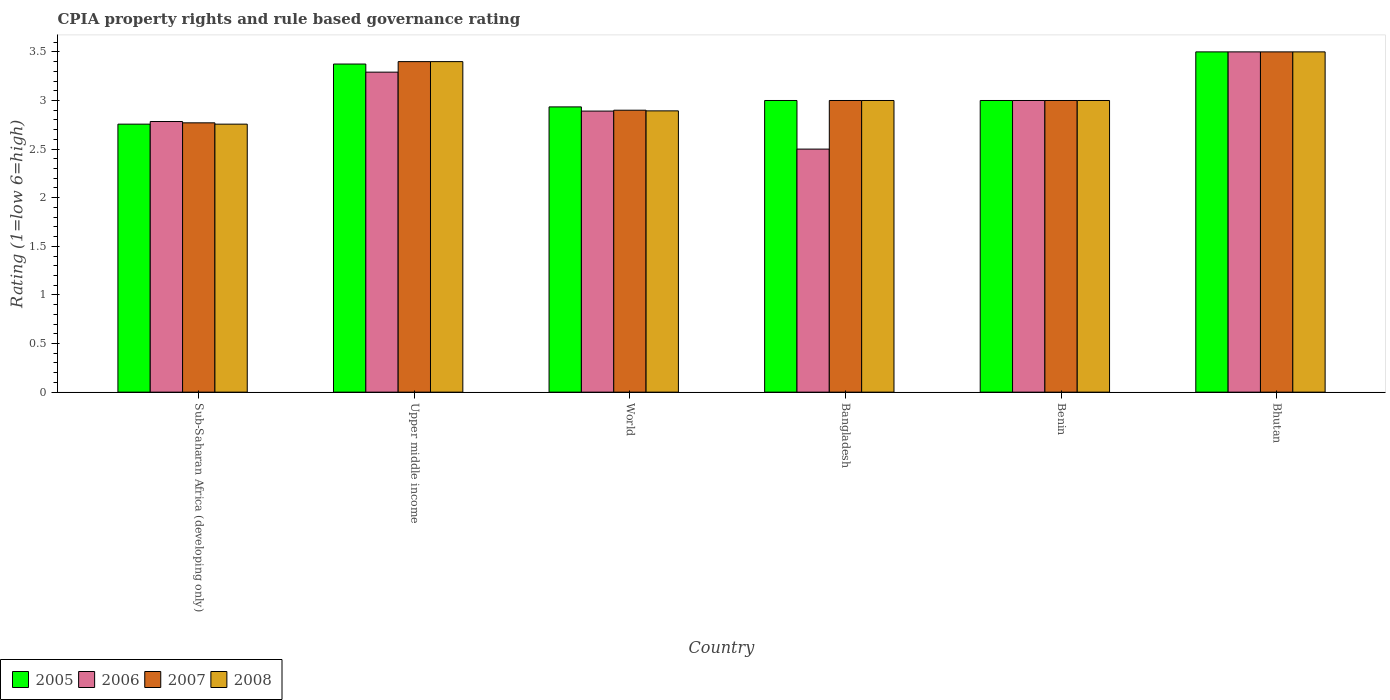How many different coloured bars are there?
Give a very brief answer. 4. How many groups of bars are there?
Ensure brevity in your answer.  6. Are the number of bars on each tick of the X-axis equal?
Your response must be concise. Yes. How many bars are there on the 5th tick from the left?
Give a very brief answer. 4. How many bars are there on the 6th tick from the right?
Ensure brevity in your answer.  4. What is the label of the 2nd group of bars from the left?
Your answer should be compact. Upper middle income. In how many cases, is the number of bars for a given country not equal to the number of legend labels?
Give a very brief answer. 0. What is the CPIA rating in 2008 in Sub-Saharan Africa (developing only)?
Keep it short and to the point. 2.76. Across all countries, what is the maximum CPIA rating in 2007?
Your answer should be compact. 3.5. Across all countries, what is the minimum CPIA rating in 2007?
Keep it short and to the point. 2.77. In which country was the CPIA rating in 2006 maximum?
Your answer should be very brief. Bhutan. In which country was the CPIA rating in 2007 minimum?
Your response must be concise. Sub-Saharan Africa (developing only). What is the total CPIA rating in 2008 in the graph?
Provide a succinct answer. 18.55. What is the difference between the CPIA rating in 2008 in Bangladesh and that in Sub-Saharan Africa (developing only)?
Offer a very short reply. 0.24. What is the difference between the CPIA rating in 2006 in Benin and the CPIA rating in 2007 in Sub-Saharan Africa (developing only)?
Your answer should be very brief. 0.23. What is the average CPIA rating in 2006 per country?
Offer a very short reply. 2.99. What is the difference between the CPIA rating of/in 2007 and CPIA rating of/in 2006 in Benin?
Ensure brevity in your answer.  0. In how many countries, is the CPIA rating in 2006 greater than 0.9?
Keep it short and to the point. 6. What is the ratio of the CPIA rating in 2006 in Upper middle income to that in World?
Offer a terse response. 1.14. Is the CPIA rating in 2007 in Bhutan less than that in Upper middle income?
Your response must be concise. No. Is the difference between the CPIA rating in 2007 in Bangladesh and World greater than the difference between the CPIA rating in 2006 in Bangladesh and World?
Your answer should be very brief. Yes. What is the difference between the highest and the second highest CPIA rating in 2008?
Keep it short and to the point. 0.4. What is the difference between the highest and the lowest CPIA rating in 2007?
Keep it short and to the point. 0.73. In how many countries, is the CPIA rating in 2008 greater than the average CPIA rating in 2008 taken over all countries?
Provide a short and direct response. 2. Is the sum of the CPIA rating in 2006 in Benin and World greater than the maximum CPIA rating in 2005 across all countries?
Your answer should be very brief. Yes. Is it the case that in every country, the sum of the CPIA rating in 2007 and CPIA rating in 2005 is greater than the sum of CPIA rating in 2008 and CPIA rating in 2006?
Provide a succinct answer. Yes. What does the 4th bar from the left in Benin represents?
Your response must be concise. 2008. What does the 4th bar from the right in Benin represents?
Provide a succinct answer. 2005. Are all the bars in the graph horizontal?
Keep it short and to the point. No. How many countries are there in the graph?
Make the answer very short. 6. What is the difference between two consecutive major ticks on the Y-axis?
Your answer should be very brief. 0.5. Does the graph contain any zero values?
Your answer should be very brief. No. How many legend labels are there?
Give a very brief answer. 4. What is the title of the graph?
Offer a very short reply. CPIA property rights and rule based governance rating. Does "1999" appear as one of the legend labels in the graph?
Your answer should be very brief. No. What is the label or title of the X-axis?
Keep it short and to the point. Country. What is the Rating (1=low 6=high) in 2005 in Sub-Saharan Africa (developing only)?
Offer a very short reply. 2.76. What is the Rating (1=low 6=high) of 2006 in Sub-Saharan Africa (developing only)?
Provide a succinct answer. 2.78. What is the Rating (1=low 6=high) in 2007 in Sub-Saharan Africa (developing only)?
Your answer should be very brief. 2.77. What is the Rating (1=low 6=high) of 2008 in Sub-Saharan Africa (developing only)?
Offer a very short reply. 2.76. What is the Rating (1=low 6=high) of 2005 in Upper middle income?
Your answer should be very brief. 3.38. What is the Rating (1=low 6=high) in 2006 in Upper middle income?
Give a very brief answer. 3.29. What is the Rating (1=low 6=high) in 2005 in World?
Provide a short and direct response. 2.93. What is the Rating (1=low 6=high) in 2006 in World?
Keep it short and to the point. 2.89. What is the Rating (1=low 6=high) in 2007 in World?
Offer a very short reply. 2.9. What is the Rating (1=low 6=high) of 2008 in World?
Provide a short and direct response. 2.89. What is the Rating (1=low 6=high) of 2006 in Bangladesh?
Provide a short and direct response. 2.5. What is the Rating (1=low 6=high) of 2008 in Bangladesh?
Give a very brief answer. 3. What is the Rating (1=low 6=high) of 2005 in Benin?
Ensure brevity in your answer.  3. What is the Rating (1=low 6=high) of 2008 in Benin?
Give a very brief answer. 3. What is the Rating (1=low 6=high) of 2007 in Bhutan?
Your answer should be very brief. 3.5. What is the Rating (1=low 6=high) in 2008 in Bhutan?
Ensure brevity in your answer.  3.5. Across all countries, what is the maximum Rating (1=low 6=high) in 2005?
Your answer should be compact. 3.5. Across all countries, what is the maximum Rating (1=low 6=high) of 2007?
Your response must be concise. 3.5. Across all countries, what is the maximum Rating (1=low 6=high) of 2008?
Make the answer very short. 3.5. Across all countries, what is the minimum Rating (1=low 6=high) of 2005?
Your answer should be compact. 2.76. Across all countries, what is the minimum Rating (1=low 6=high) of 2007?
Your response must be concise. 2.77. Across all countries, what is the minimum Rating (1=low 6=high) in 2008?
Provide a short and direct response. 2.76. What is the total Rating (1=low 6=high) of 2005 in the graph?
Offer a terse response. 18.57. What is the total Rating (1=low 6=high) in 2006 in the graph?
Your answer should be compact. 17.97. What is the total Rating (1=low 6=high) of 2007 in the graph?
Your answer should be compact. 18.57. What is the total Rating (1=low 6=high) in 2008 in the graph?
Provide a short and direct response. 18.55. What is the difference between the Rating (1=low 6=high) of 2005 in Sub-Saharan Africa (developing only) and that in Upper middle income?
Ensure brevity in your answer.  -0.62. What is the difference between the Rating (1=low 6=high) in 2006 in Sub-Saharan Africa (developing only) and that in Upper middle income?
Keep it short and to the point. -0.51. What is the difference between the Rating (1=low 6=high) of 2007 in Sub-Saharan Africa (developing only) and that in Upper middle income?
Your response must be concise. -0.63. What is the difference between the Rating (1=low 6=high) in 2008 in Sub-Saharan Africa (developing only) and that in Upper middle income?
Offer a very short reply. -0.64. What is the difference between the Rating (1=low 6=high) in 2005 in Sub-Saharan Africa (developing only) and that in World?
Give a very brief answer. -0.18. What is the difference between the Rating (1=low 6=high) in 2006 in Sub-Saharan Africa (developing only) and that in World?
Your answer should be compact. -0.11. What is the difference between the Rating (1=low 6=high) of 2007 in Sub-Saharan Africa (developing only) and that in World?
Keep it short and to the point. -0.13. What is the difference between the Rating (1=low 6=high) of 2008 in Sub-Saharan Africa (developing only) and that in World?
Your response must be concise. -0.14. What is the difference between the Rating (1=low 6=high) of 2005 in Sub-Saharan Africa (developing only) and that in Bangladesh?
Keep it short and to the point. -0.24. What is the difference between the Rating (1=low 6=high) in 2006 in Sub-Saharan Africa (developing only) and that in Bangladesh?
Offer a very short reply. 0.28. What is the difference between the Rating (1=low 6=high) of 2007 in Sub-Saharan Africa (developing only) and that in Bangladesh?
Keep it short and to the point. -0.23. What is the difference between the Rating (1=low 6=high) in 2008 in Sub-Saharan Africa (developing only) and that in Bangladesh?
Ensure brevity in your answer.  -0.24. What is the difference between the Rating (1=low 6=high) in 2005 in Sub-Saharan Africa (developing only) and that in Benin?
Your answer should be compact. -0.24. What is the difference between the Rating (1=low 6=high) in 2006 in Sub-Saharan Africa (developing only) and that in Benin?
Make the answer very short. -0.22. What is the difference between the Rating (1=low 6=high) of 2007 in Sub-Saharan Africa (developing only) and that in Benin?
Your answer should be compact. -0.23. What is the difference between the Rating (1=low 6=high) of 2008 in Sub-Saharan Africa (developing only) and that in Benin?
Your response must be concise. -0.24. What is the difference between the Rating (1=low 6=high) in 2005 in Sub-Saharan Africa (developing only) and that in Bhutan?
Your answer should be very brief. -0.74. What is the difference between the Rating (1=low 6=high) of 2006 in Sub-Saharan Africa (developing only) and that in Bhutan?
Make the answer very short. -0.72. What is the difference between the Rating (1=low 6=high) of 2007 in Sub-Saharan Africa (developing only) and that in Bhutan?
Provide a succinct answer. -0.73. What is the difference between the Rating (1=low 6=high) in 2008 in Sub-Saharan Africa (developing only) and that in Bhutan?
Offer a very short reply. -0.74. What is the difference between the Rating (1=low 6=high) of 2005 in Upper middle income and that in World?
Offer a terse response. 0.44. What is the difference between the Rating (1=low 6=high) of 2006 in Upper middle income and that in World?
Your answer should be very brief. 0.4. What is the difference between the Rating (1=low 6=high) in 2007 in Upper middle income and that in World?
Ensure brevity in your answer.  0.5. What is the difference between the Rating (1=low 6=high) in 2008 in Upper middle income and that in World?
Your answer should be compact. 0.51. What is the difference between the Rating (1=low 6=high) in 2006 in Upper middle income and that in Bangladesh?
Your answer should be compact. 0.79. What is the difference between the Rating (1=low 6=high) in 2007 in Upper middle income and that in Bangladesh?
Your answer should be very brief. 0.4. What is the difference between the Rating (1=low 6=high) in 2005 in Upper middle income and that in Benin?
Offer a very short reply. 0.38. What is the difference between the Rating (1=low 6=high) in 2006 in Upper middle income and that in Benin?
Your answer should be very brief. 0.29. What is the difference between the Rating (1=low 6=high) of 2008 in Upper middle income and that in Benin?
Ensure brevity in your answer.  0.4. What is the difference between the Rating (1=low 6=high) of 2005 in Upper middle income and that in Bhutan?
Offer a terse response. -0.12. What is the difference between the Rating (1=low 6=high) in 2006 in Upper middle income and that in Bhutan?
Offer a very short reply. -0.21. What is the difference between the Rating (1=low 6=high) in 2007 in Upper middle income and that in Bhutan?
Make the answer very short. -0.1. What is the difference between the Rating (1=low 6=high) in 2008 in Upper middle income and that in Bhutan?
Offer a terse response. -0.1. What is the difference between the Rating (1=low 6=high) in 2005 in World and that in Bangladesh?
Ensure brevity in your answer.  -0.07. What is the difference between the Rating (1=low 6=high) in 2006 in World and that in Bangladesh?
Give a very brief answer. 0.39. What is the difference between the Rating (1=low 6=high) of 2008 in World and that in Bangladesh?
Give a very brief answer. -0.11. What is the difference between the Rating (1=low 6=high) in 2005 in World and that in Benin?
Your answer should be compact. -0.07. What is the difference between the Rating (1=low 6=high) in 2006 in World and that in Benin?
Provide a succinct answer. -0.11. What is the difference between the Rating (1=low 6=high) in 2008 in World and that in Benin?
Your response must be concise. -0.11. What is the difference between the Rating (1=low 6=high) in 2005 in World and that in Bhutan?
Your answer should be very brief. -0.57. What is the difference between the Rating (1=low 6=high) in 2006 in World and that in Bhutan?
Ensure brevity in your answer.  -0.61. What is the difference between the Rating (1=low 6=high) in 2008 in World and that in Bhutan?
Make the answer very short. -0.61. What is the difference between the Rating (1=low 6=high) of 2005 in Bangladesh and that in Benin?
Offer a very short reply. 0. What is the difference between the Rating (1=low 6=high) in 2006 in Bangladesh and that in Benin?
Offer a terse response. -0.5. What is the difference between the Rating (1=low 6=high) of 2008 in Bangladesh and that in Benin?
Make the answer very short. 0. What is the difference between the Rating (1=low 6=high) in 2005 in Bangladesh and that in Bhutan?
Offer a terse response. -0.5. What is the difference between the Rating (1=low 6=high) in 2006 in Bangladesh and that in Bhutan?
Your response must be concise. -1. What is the difference between the Rating (1=low 6=high) of 2007 in Bangladesh and that in Bhutan?
Ensure brevity in your answer.  -0.5. What is the difference between the Rating (1=low 6=high) in 2008 in Bangladesh and that in Bhutan?
Keep it short and to the point. -0.5. What is the difference between the Rating (1=low 6=high) of 2005 in Benin and that in Bhutan?
Make the answer very short. -0.5. What is the difference between the Rating (1=low 6=high) in 2007 in Benin and that in Bhutan?
Your answer should be compact. -0.5. What is the difference between the Rating (1=low 6=high) of 2005 in Sub-Saharan Africa (developing only) and the Rating (1=low 6=high) of 2006 in Upper middle income?
Offer a very short reply. -0.53. What is the difference between the Rating (1=low 6=high) of 2005 in Sub-Saharan Africa (developing only) and the Rating (1=low 6=high) of 2007 in Upper middle income?
Make the answer very short. -0.64. What is the difference between the Rating (1=low 6=high) in 2005 in Sub-Saharan Africa (developing only) and the Rating (1=low 6=high) in 2008 in Upper middle income?
Your answer should be compact. -0.64. What is the difference between the Rating (1=low 6=high) in 2006 in Sub-Saharan Africa (developing only) and the Rating (1=low 6=high) in 2007 in Upper middle income?
Offer a very short reply. -0.62. What is the difference between the Rating (1=low 6=high) of 2006 in Sub-Saharan Africa (developing only) and the Rating (1=low 6=high) of 2008 in Upper middle income?
Keep it short and to the point. -0.62. What is the difference between the Rating (1=low 6=high) of 2007 in Sub-Saharan Africa (developing only) and the Rating (1=low 6=high) of 2008 in Upper middle income?
Keep it short and to the point. -0.63. What is the difference between the Rating (1=low 6=high) in 2005 in Sub-Saharan Africa (developing only) and the Rating (1=low 6=high) in 2006 in World?
Ensure brevity in your answer.  -0.13. What is the difference between the Rating (1=low 6=high) in 2005 in Sub-Saharan Africa (developing only) and the Rating (1=low 6=high) in 2007 in World?
Offer a very short reply. -0.14. What is the difference between the Rating (1=low 6=high) in 2005 in Sub-Saharan Africa (developing only) and the Rating (1=low 6=high) in 2008 in World?
Your answer should be very brief. -0.14. What is the difference between the Rating (1=low 6=high) of 2006 in Sub-Saharan Africa (developing only) and the Rating (1=low 6=high) of 2007 in World?
Your response must be concise. -0.12. What is the difference between the Rating (1=low 6=high) in 2006 in Sub-Saharan Africa (developing only) and the Rating (1=low 6=high) in 2008 in World?
Your answer should be very brief. -0.11. What is the difference between the Rating (1=low 6=high) of 2007 in Sub-Saharan Africa (developing only) and the Rating (1=low 6=high) of 2008 in World?
Provide a succinct answer. -0.12. What is the difference between the Rating (1=low 6=high) of 2005 in Sub-Saharan Africa (developing only) and the Rating (1=low 6=high) of 2006 in Bangladesh?
Offer a terse response. 0.26. What is the difference between the Rating (1=low 6=high) in 2005 in Sub-Saharan Africa (developing only) and the Rating (1=low 6=high) in 2007 in Bangladesh?
Ensure brevity in your answer.  -0.24. What is the difference between the Rating (1=low 6=high) of 2005 in Sub-Saharan Africa (developing only) and the Rating (1=low 6=high) of 2008 in Bangladesh?
Offer a very short reply. -0.24. What is the difference between the Rating (1=low 6=high) of 2006 in Sub-Saharan Africa (developing only) and the Rating (1=low 6=high) of 2007 in Bangladesh?
Keep it short and to the point. -0.22. What is the difference between the Rating (1=low 6=high) of 2006 in Sub-Saharan Africa (developing only) and the Rating (1=low 6=high) of 2008 in Bangladesh?
Your answer should be compact. -0.22. What is the difference between the Rating (1=low 6=high) of 2007 in Sub-Saharan Africa (developing only) and the Rating (1=low 6=high) of 2008 in Bangladesh?
Provide a succinct answer. -0.23. What is the difference between the Rating (1=low 6=high) of 2005 in Sub-Saharan Africa (developing only) and the Rating (1=low 6=high) of 2006 in Benin?
Give a very brief answer. -0.24. What is the difference between the Rating (1=low 6=high) of 2005 in Sub-Saharan Africa (developing only) and the Rating (1=low 6=high) of 2007 in Benin?
Make the answer very short. -0.24. What is the difference between the Rating (1=low 6=high) in 2005 in Sub-Saharan Africa (developing only) and the Rating (1=low 6=high) in 2008 in Benin?
Provide a succinct answer. -0.24. What is the difference between the Rating (1=low 6=high) of 2006 in Sub-Saharan Africa (developing only) and the Rating (1=low 6=high) of 2007 in Benin?
Provide a short and direct response. -0.22. What is the difference between the Rating (1=low 6=high) of 2006 in Sub-Saharan Africa (developing only) and the Rating (1=low 6=high) of 2008 in Benin?
Your answer should be very brief. -0.22. What is the difference between the Rating (1=low 6=high) in 2007 in Sub-Saharan Africa (developing only) and the Rating (1=low 6=high) in 2008 in Benin?
Offer a very short reply. -0.23. What is the difference between the Rating (1=low 6=high) in 2005 in Sub-Saharan Africa (developing only) and the Rating (1=low 6=high) in 2006 in Bhutan?
Provide a succinct answer. -0.74. What is the difference between the Rating (1=low 6=high) of 2005 in Sub-Saharan Africa (developing only) and the Rating (1=low 6=high) of 2007 in Bhutan?
Your answer should be very brief. -0.74. What is the difference between the Rating (1=low 6=high) of 2005 in Sub-Saharan Africa (developing only) and the Rating (1=low 6=high) of 2008 in Bhutan?
Your answer should be very brief. -0.74. What is the difference between the Rating (1=low 6=high) of 2006 in Sub-Saharan Africa (developing only) and the Rating (1=low 6=high) of 2007 in Bhutan?
Offer a very short reply. -0.72. What is the difference between the Rating (1=low 6=high) in 2006 in Sub-Saharan Africa (developing only) and the Rating (1=low 6=high) in 2008 in Bhutan?
Offer a terse response. -0.72. What is the difference between the Rating (1=low 6=high) of 2007 in Sub-Saharan Africa (developing only) and the Rating (1=low 6=high) of 2008 in Bhutan?
Your response must be concise. -0.73. What is the difference between the Rating (1=low 6=high) of 2005 in Upper middle income and the Rating (1=low 6=high) of 2006 in World?
Your response must be concise. 0.48. What is the difference between the Rating (1=low 6=high) in 2005 in Upper middle income and the Rating (1=low 6=high) in 2007 in World?
Offer a very short reply. 0.47. What is the difference between the Rating (1=low 6=high) in 2005 in Upper middle income and the Rating (1=low 6=high) in 2008 in World?
Provide a short and direct response. 0.48. What is the difference between the Rating (1=low 6=high) in 2006 in Upper middle income and the Rating (1=low 6=high) in 2007 in World?
Your answer should be compact. 0.39. What is the difference between the Rating (1=low 6=high) of 2006 in Upper middle income and the Rating (1=low 6=high) of 2008 in World?
Offer a terse response. 0.4. What is the difference between the Rating (1=low 6=high) in 2007 in Upper middle income and the Rating (1=low 6=high) in 2008 in World?
Give a very brief answer. 0.51. What is the difference between the Rating (1=low 6=high) in 2006 in Upper middle income and the Rating (1=low 6=high) in 2007 in Bangladesh?
Your answer should be very brief. 0.29. What is the difference between the Rating (1=low 6=high) of 2006 in Upper middle income and the Rating (1=low 6=high) of 2008 in Bangladesh?
Ensure brevity in your answer.  0.29. What is the difference between the Rating (1=low 6=high) in 2006 in Upper middle income and the Rating (1=low 6=high) in 2007 in Benin?
Provide a short and direct response. 0.29. What is the difference between the Rating (1=low 6=high) in 2006 in Upper middle income and the Rating (1=low 6=high) in 2008 in Benin?
Provide a succinct answer. 0.29. What is the difference between the Rating (1=low 6=high) in 2005 in Upper middle income and the Rating (1=low 6=high) in 2006 in Bhutan?
Give a very brief answer. -0.12. What is the difference between the Rating (1=low 6=high) of 2005 in Upper middle income and the Rating (1=low 6=high) of 2007 in Bhutan?
Offer a terse response. -0.12. What is the difference between the Rating (1=low 6=high) in 2005 in Upper middle income and the Rating (1=low 6=high) in 2008 in Bhutan?
Offer a very short reply. -0.12. What is the difference between the Rating (1=low 6=high) in 2006 in Upper middle income and the Rating (1=low 6=high) in 2007 in Bhutan?
Keep it short and to the point. -0.21. What is the difference between the Rating (1=low 6=high) of 2006 in Upper middle income and the Rating (1=low 6=high) of 2008 in Bhutan?
Your response must be concise. -0.21. What is the difference between the Rating (1=low 6=high) of 2007 in Upper middle income and the Rating (1=low 6=high) of 2008 in Bhutan?
Your answer should be very brief. -0.1. What is the difference between the Rating (1=low 6=high) in 2005 in World and the Rating (1=low 6=high) in 2006 in Bangladesh?
Give a very brief answer. 0.43. What is the difference between the Rating (1=low 6=high) of 2005 in World and the Rating (1=low 6=high) of 2007 in Bangladesh?
Keep it short and to the point. -0.07. What is the difference between the Rating (1=low 6=high) of 2005 in World and the Rating (1=low 6=high) of 2008 in Bangladesh?
Your answer should be very brief. -0.07. What is the difference between the Rating (1=low 6=high) in 2006 in World and the Rating (1=low 6=high) in 2007 in Bangladesh?
Make the answer very short. -0.11. What is the difference between the Rating (1=low 6=high) of 2006 in World and the Rating (1=low 6=high) of 2008 in Bangladesh?
Offer a terse response. -0.11. What is the difference between the Rating (1=low 6=high) of 2005 in World and the Rating (1=low 6=high) of 2006 in Benin?
Offer a very short reply. -0.07. What is the difference between the Rating (1=low 6=high) of 2005 in World and the Rating (1=low 6=high) of 2007 in Benin?
Give a very brief answer. -0.07. What is the difference between the Rating (1=low 6=high) in 2005 in World and the Rating (1=low 6=high) in 2008 in Benin?
Your answer should be very brief. -0.07. What is the difference between the Rating (1=low 6=high) of 2006 in World and the Rating (1=low 6=high) of 2007 in Benin?
Keep it short and to the point. -0.11. What is the difference between the Rating (1=low 6=high) of 2006 in World and the Rating (1=low 6=high) of 2008 in Benin?
Your response must be concise. -0.11. What is the difference between the Rating (1=low 6=high) of 2005 in World and the Rating (1=low 6=high) of 2006 in Bhutan?
Provide a short and direct response. -0.57. What is the difference between the Rating (1=low 6=high) of 2005 in World and the Rating (1=low 6=high) of 2007 in Bhutan?
Give a very brief answer. -0.57. What is the difference between the Rating (1=low 6=high) in 2005 in World and the Rating (1=low 6=high) in 2008 in Bhutan?
Keep it short and to the point. -0.57. What is the difference between the Rating (1=low 6=high) in 2006 in World and the Rating (1=low 6=high) in 2007 in Bhutan?
Provide a short and direct response. -0.61. What is the difference between the Rating (1=low 6=high) in 2006 in World and the Rating (1=low 6=high) in 2008 in Bhutan?
Make the answer very short. -0.61. What is the difference between the Rating (1=low 6=high) of 2005 in Bangladesh and the Rating (1=low 6=high) of 2006 in Benin?
Offer a very short reply. 0. What is the difference between the Rating (1=low 6=high) in 2006 in Bangladesh and the Rating (1=low 6=high) in 2007 in Benin?
Provide a short and direct response. -0.5. What is the difference between the Rating (1=low 6=high) of 2005 in Bangladesh and the Rating (1=low 6=high) of 2008 in Bhutan?
Provide a short and direct response. -0.5. What is the difference between the Rating (1=low 6=high) in 2006 in Bangladesh and the Rating (1=low 6=high) in 2007 in Bhutan?
Your answer should be compact. -1. What is the difference between the Rating (1=low 6=high) in 2006 in Bangladesh and the Rating (1=low 6=high) in 2008 in Bhutan?
Give a very brief answer. -1. What is the difference between the Rating (1=low 6=high) of 2007 in Bangladesh and the Rating (1=low 6=high) of 2008 in Bhutan?
Your response must be concise. -0.5. What is the difference between the Rating (1=low 6=high) of 2005 in Benin and the Rating (1=low 6=high) of 2006 in Bhutan?
Your response must be concise. -0.5. What is the difference between the Rating (1=low 6=high) of 2005 in Benin and the Rating (1=low 6=high) of 2007 in Bhutan?
Your response must be concise. -0.5. What is the difference between the Rating (1=low 6=high) in 2005 in Benin and the Rating (1=low 6=high) in 2008 in Bhutan?
Give a very brief answer. -0.5. What is the difference between the Rating (1=low 6=high) in 2006 in Benin and the Rating (1=low 6=high) in 2007 in Bhutan?
Keep it short and to the point. -0.5. What is the average Rating (1=low 6=high) in 2005 per country?
Offer a terse response. 3.09. What is the average Rating (1=low 6=high) in 2006 per country?
Offer a very short reply. 2.99. What is the average Rating (1=low 6=high) in 2007 per country?
Your answer should be very brief. 3.1. What is the average Rating (1=low 6=high) of 2008 per country?
Give a very brief answer. 3.09. What is the difference between the Rating (1=low 6=high) of 2005 and Rating (1=low 6=high) of 2006 in Sub-Saharan Africa (developing only)?
Provide a short and direct response. -0.03. What is the difference between the Rating (1=low 6=high) in 2005 and Rating (1=low 6=high) in 2007 in Sub-Saharan Africa (developing only)?
Give a very brief answer. -0.01. What is the difference between the Rating (1=low 6=high) of 2005 and Rating (1=low 6=high) of 2008 in Sub-Saharan Africa (developing only)?
Provide a short and direct response. 0. What is the difference between the Rating (1=low 6=high) in 2006 and Rating (1=low 6=high) in 2007 in Sub-Saharan Africa (developing only)?
Provide a short and direct response. 0.01. What is the difference between the Rating (1=low 6=high) in 2006 and Rating (1=low 6=high) in 2008 in Sub-Saharan Africa (developing only)?
Make the answer very short. 0.03. What is the difference between the Rating (1=low 6=high) in 2007 and Rating (1=low 6=high) in 2008 in Sub-Saharan Africa (developing only)?
Ensure brevity in your answer.  0.01. What is the difference between the Rating (1=low 6=high) in 2005 and Rating (1=low 6=high) in 2006 in Upper middle income?
Provide a succinct answer. 0.08. What is the difference between the Rating (1=low 6=high) of 2005 and Rating (1=low 6=high) of 2007 in Upper middle income?
Provide a succinct answer. -0.03. What is the difference between the Rating (1=low 6=high) of 2005 and Rating (1=low 6=high) of 2008 in Upper middle income?
Provide a succinct answer. -0.03. What is the difference between the Rating (1=low 6=high) in 2006 and Rating (1=low 6=high) in 2007 in Upper middle income?
Provide a short and direct response. -0.11. What is the difference between the Rating (1=low 6=high) of 2006 and Rating (1=low 6=high) of 2008 in Upper middle income?
Offer a very short reply. -0.11. What is the difference between the Rating (1=low 6=high) in 2005 and Rating (1=low 6=high) in 2006 in World?
Your answer should be compact. 0.04. What is the difference between the Rating (1=low 6=high) in 2005 and Rating (1=low 6=high) in 2007 in World?
Your response must be concise. 0.03. What is the difference between the Rating (1=low 6=high) of 2005 and Rating (1=low 6=high) of 2008 in World?
Provide a succinct answer. 0.04. What is the difference between the Rating (1=low 6=high) of 2006 and Rating (1=low 6=high) of 2007 in World?
Give a very brief answer. -0.01. What is the difference between the Rating (1=low 6=high) of 2006 and Rating (1=low 6=high) of 2008 in World?
Provide a succinct answer. -0. What is the difference between the Rating (1=low 6=high) of 2007 and Rating (1=low 6=high) of 2008 in World?
Ensure brevity in your answer.  0.01. What is the difference between the Rating (1=low 6=high) of 2005 and Rating (1=low 6=high) of 2006 in Bangladesh?
Offer a terse response. 0.5. What is the difference between the Rating (1=low 6=high) of 2005 and Rating (1=low 6=high) of 2008 in Bangladesh?
Offer a very short reply. 0. What is the difference between the Rating (1=low 6=high) in 2006 and Rating (1=low 6=high) in 2007 in Bangladesh?
Offer a very short reply. -0.5. What is the difference between the Rating (1=low 6=high) in 2006 and Rating (1=low 6=high) in 2008 in Bangladesh?
Give a very brief answer. -0.5. What is the difference between the Rating (1=low 6=high) in 2007 and Rating (1=low 6=high) in 2008 in Bangladesh?
Ensure brevity in your answer.  0. What is the difference between the Rating (1=low 6=high) of 2005 and Rating (1=low 6=high) of 2006 in Benin?
Provide a succinct answer. 0. What is the difference between the Rating (1=low 6=high) of 2005 and Rating (1=low 6=high) of 2007 in Benin?
Your answer should be very brief. 0. What is the difference between the Rating (1=low 6=high) in 2007 and Rating (1=low 6=high) in 2008 in Benin?
Give a very brief answer. 0. What is the difference between the Rating (1=low 6=high) in 2005 and Rating (1=low 6=high) in 2006 in Bhutan?
Provide a short and direct response. 0. What is the difference between the Rating (1=low 6=high) of 2005 and Rating (1=low 6=high) of 2007 in Bhutan?
Offer a terse response. 0. What is the difference between the Rating (1=low 6=high) of 2005 and Rating (1=low 6=high) of 2008 in Bhutan?
Your response must be concise. 0. What is the difference between the Rating (1=low 6=high) in 2006 and Rating (1=low 6=high) in 2007 in Bhutan?
Keep it short and to the point. 0. What is the ratio of the Rating (1=low 6=high) of 2005 in Sub-Saharan Africa (developing only) to that in Upper middle income?
Offer a terse response. 0.82. What is the ratio of the Rating (1=low 6=high) in 2006 in Sub-Saharan Africa (developing only) to that in Upper middle income?
Offer a very short reply. 0.85. What is the ratio of the Rating (1=low 6=high) of 2007 in Sub-Saharan Africa (developing only) to that in Upper middle income?
Provide a succinct answer. 0.81. What is the ratio of the Rating (1=low 6=high) of 2008 in Sub-Saharan Africa (developing only) to that in Upper middle income?
Your answer should be very brief. 0.81. What is the ratio of the Rating (1=low 6=high) of 2005 in Sub-Saharan Africa (developing only) to that in World?
Your response must be concise. 0.94. What is the ratio of the Rating (1=low 6=high) in 2006 in Sub-Saharan Africa (developing only) to that in World?
Your response must be concise. 0.96. What is the ratio of the Rating (1=low 6=high) of 2007 in Sub-Saharan Africa (developing only) to that in World?
Your answer should be very brief. 0.96. What is the ratio of the Rating (1=low 6=high) in 2008 in Sub-Saharan Africa (developing only) to that in World?
Provide a short and direct response. 0.95. What is the ratio of the Rating (1=low 6=high) in 2005 in Sub-Saharan Africa (developing only) to that in Bangladesh?
Keep it short and to the point. 0.92. What is the ratio of the Rating (1=low 6=high) of 2006 in Sub-Saharan Africa (developing only) to that in Bangladesh?
Ensure brevity in your answer.  1.11. What is the ratio of the Rating (1=low 6=high) of 2007 in Sub-Saharan Africa (developing only) to that in Bangladesh?
Ensure brevity in your answer.  0.92. What is the ratio of the Rating (1=low 6=high) of 2008 in Sub-Saharan Africa (developing only) to that in Bangladesh?
Offer a terse response. 0.92. What is the ratio of the Rating (1=low 6=high) of 2005 in Sub-Saharan Africa (developing only) to that in Benin?
Offer a very short reply. 0.92. What is the ratio of the Rating (1=low 6=high) of 2006 in Sub-Saharan Africa (developing only) to that in Benin?
Ensure brevity in your answer.  0.93. What is the ratio of the Rating (1=low 6=high) of 2007 in Sub-Saharan Africa (developing only) to that in Benin?
Offer a very short reply. 0.92. What is the ratio of the Rating (1=low 6=high) of 2008 in Sub-Saharan Africa (developing only) to that in Benin?
Your response must be concise. 0.92. What is the ratio of the Rating (1=low 6=high) of 2005 in Sub-Saharan Africa (developing only) to that in Bhutan?
Give a very brief answer. 0.79. What is the ratio of the Rating (1=low 6=high) of 2006 in Sub-Saharan Africa (developing only) to that in Bhutan?
Your answer should be very brief. 0.8. What is the ratio of the Rating (1=low 6=high) of 2007 in Sub-Saharan Africa (developing only) to that in Bhutan?
Ensure brevity in your answer.  0.79. What is the ratio of the Rating (1=low 6=high) in 2008 in Sub-Saharan Africa (developing only) to that in Bhutan?
Your answer should be very brief. 0.79. What is the ratio of the Rating (1=low 6=high) of 2005 in Upper middle income to that in World?
Your response must be concise. 1.15. What is the ratio of the Rating (1=low 6=high) of 2006 in Upper middle income to that in World?
Your answer should be very brief. 1.14. What is the ratio of the Rating (1=low 6=high) of 2007 in Upper middle income to that in World?
Your answer should be very brief. 1.17. What is the ratio of the Rating (1=low 6=high) of 2008 in Upper middle income to that in World?
Keep it short and to the point. 1.18. What is the ratio of the Rating (1=low 6=high) in 2006 in Upper middle income to that in Bangladesh?
Keep it short and to the point. 1.32. What is the ratio of the Rating (1=low 6=high) in 2007 in Upper middle income to that in Bangladesh?
Your answer should be very brief. 1.13. What is the ratio of the Rating (1=low 6=high) in 2008 in Upper middle income to that in Bangladesh?
Offer a terse response. 1.13. What is the ratio of the Rating (1=low 6=high) of 2006 in Upper middle income to that in Benin?
Make the answer very short. 1.1. What is the ratio of the Rating (1=low 6=high) in 2007 in Upper middle income to that in Benin?
Keep it short and to the point. 1.13. What is the ratio of the Rating (1=low 6=high) of 2008 in Upper middle income to that in Benin?
Keep it short and to the point. 1.13. What is the ratio of the Rating (1=low 6=high) in 2005 in Upper middle income to that in Bhutan?
Keep it short and to the point. 0.96. What is the ratio of the Rating (1=low 6=high) of 2006 in Upper middle income to that in Bhutan?
Offer a terse response. 0.94. What is the ratio of the Rating (1=low 6=high) of 2007 in Upper middle income to that in Bhutan?
Keep it short and to the point. 0.97. What is the ratio of the Rating (1=low 6=high) of 2008 in Upper middle income to that in Bhutan?
Provide a short and direct response. 0.97. What is the ratio of the Rating (1=low 6=high) of 2005 in World to that in Bangladesh?
Offer a terse response. 0.98. What is the ratio of the Rating (1=low 6=high) of 2006 in World to that in Bangladesh?
Give a very brief answer. 1.16. What is the ratio of the Rating (1=low 6=high) in 2007 in World to that in Bangladesh?
Provide a short and direct response. 0.97. What is the ratio of the Rating (1=low 6=high) in 2008 in World to that in Bangladesh?
Make the answer very short. 0.96. What is the ratio of the Rating (1=low 6=high) in 2005 in World to that in Benin?
Your answer should be very brief. 0.98. What is the ratio of the Rating (1=low 6=high) of 2006 in World to that in Benin?
Your response must be concise. 0.96. What is the ratio of the Rating (1=low 6=high) of 2007 in World to that in Benin?
Make the answer very short. 0.97. What is the ratio of the Rating (1=low 6=high) in 2008 in World to that in Benin?
Provide a succinct answer. 0.96. What is the ratio of the Rating (1=low 6=high) of 2005 in World to that in Bhutan?
Ensure brevity in your answer.  0.84. What is the ratio of the Rating (1=low 6=high) of 2006 in World to that in Bhutan?
Offer a very short reply. 0.83. What is the ratio of the Rating (1=low 6=high) of 2007 in World to that in Bhutan?
Make the answer very short. 0.83. What is the ratio of the Rating (1=low 6=high) in 2008 in World to that in Bhutan?
Offer a very short reply. 0.83. What is the ratio of the Rating (1=low 6=high) of 2006 in Bangladesh to that in Benin?
Ensure brevity in your answer.  0.83. What is the ratio of the Rating (1=low 6=high) in 2005 in Bangladesh to that in Bhutan?
Make the answer very short. 0.86. What is the ratio of the Rating (1=low 6=high) in 2006 in Bangladesh to that in Bhutan?
Provide a short and direct response. 0.71. What is the ratio of the Rating (1=low 6=high) in 2007 in Bangladesh to that in Bhutan?
Give a very brief answer. 0.86. What is the ratio of the Rating (1=low 6=high) in 2007 in Benin to that in Bhutan?
Your answer should be very brief. 0.86. What is the ratio of the Rating (1=low 6=high) of 2008 in Benin to that in Bhutan?
Offer a terse response. 0.86. What is the difference between the highest and the second highest Rating (1=low 6=high) in 2005?
Provide a short and direct response. 0.12. What is the difference between the highest and the second highest Rating (1=low 6=high) in 2006?
Your answer should be compact. 0.21. What is the difference between the highest and the second highest Rating (1=low 6=high) in 2007?
Provide a succinct answer. 0.1. What is the difference between the highest and the lowest Rating (1=low 6=high) of 2005?
Give a very brief answer. 0.74. What is the difference between the highest and the lowest Rating (1=low 6=high) in 2006?
Give a very brief answer. 1. What is the difference between the highest and the lowest Rating (1=low 6=high) of 2007?
Keep it short and to the point. 0.73. What is the difference between the highest and the lowest Rating (1=low 6=high) in 2008?
Give a very brief answer. 0.74. 